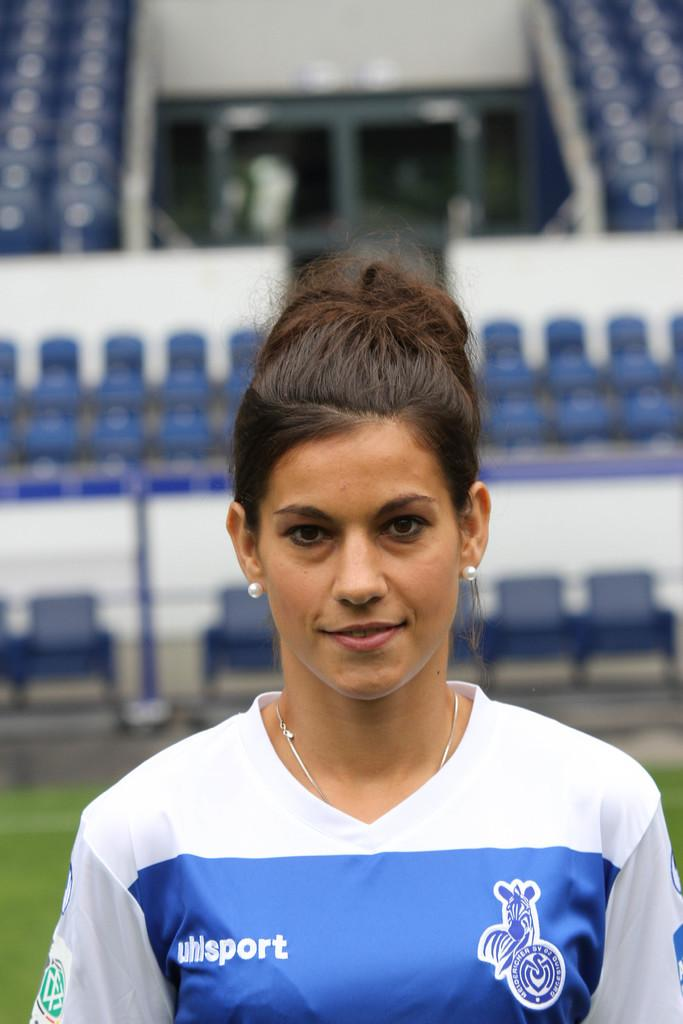<image>
Create a compact narrative representing the image presented. A girl is wearing a jersey with a uhlsport logo on it. 